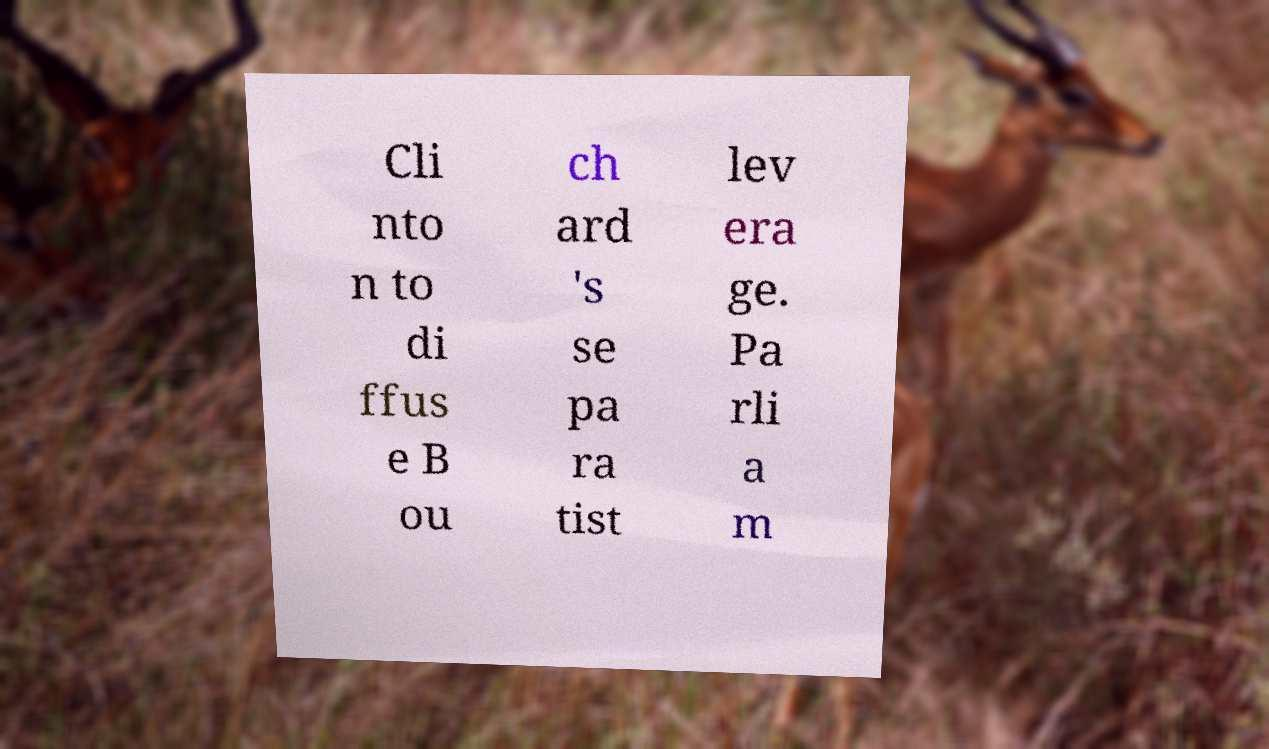Please identify and transcribe the text found in this image. Cli nto n to di ffus e B ou ch ard 's se pa ra tist lev era ge. Pa rli a m 